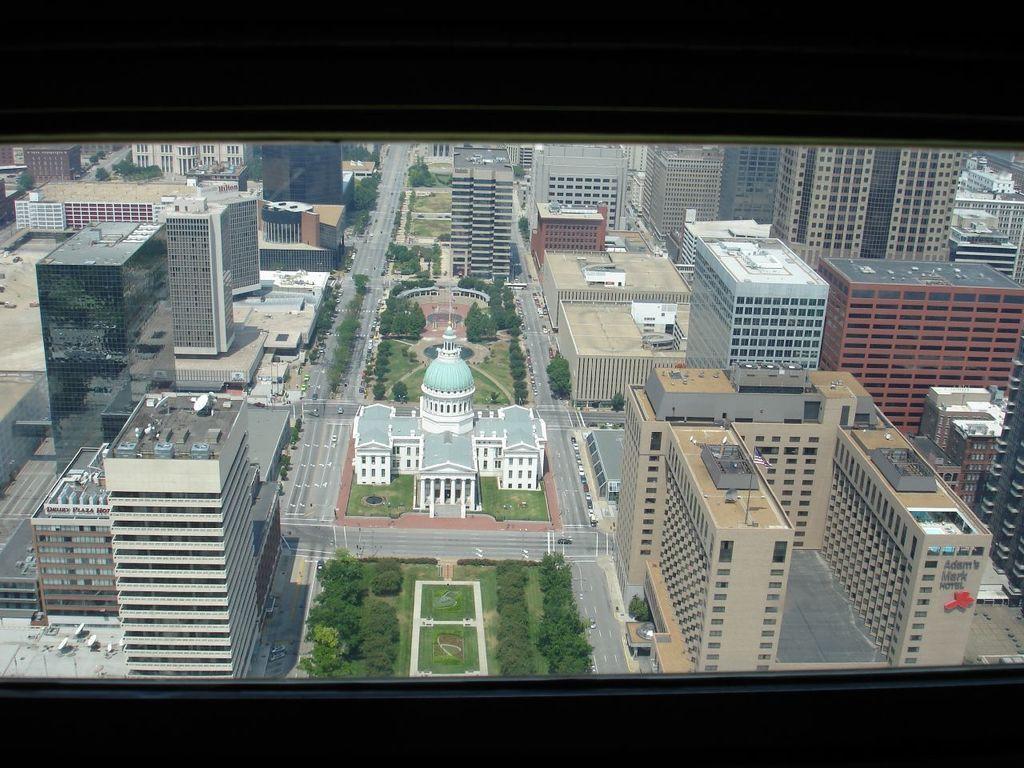Please provide a concise description of this image. In the foreground of this picture we can see the window and through the window we can see the buildings, trees, plants, green grass, vehicles and the mansion and many other objects. On the right we can see the text on the wall of the building. 